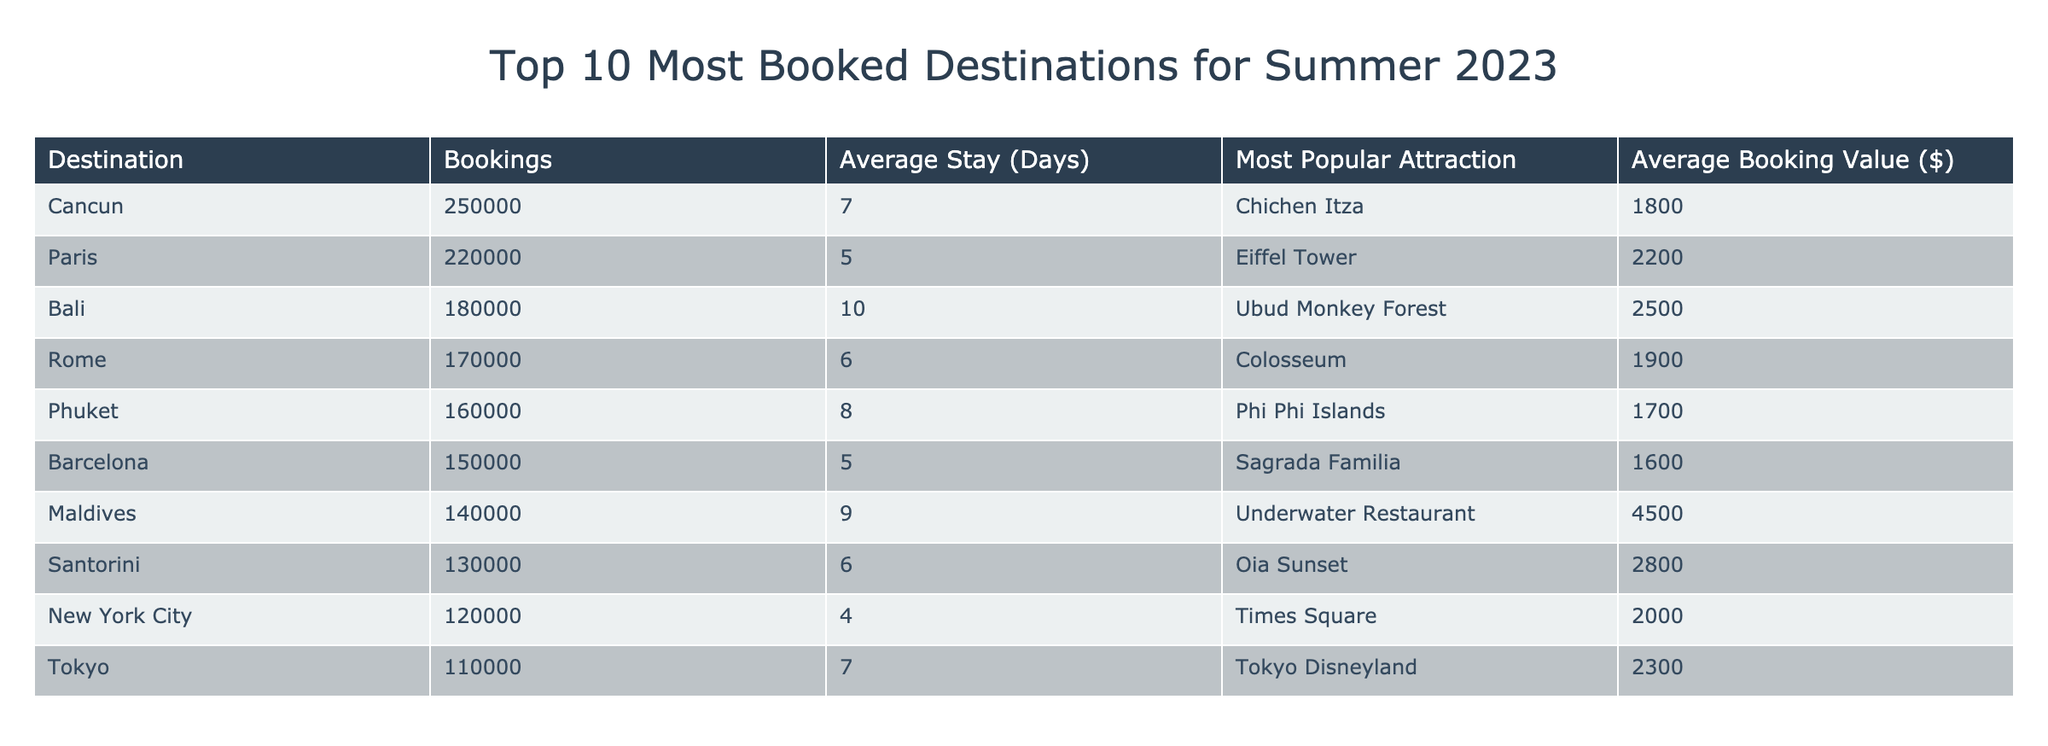What is the destination with the highest number of bookings? The destination with the highest number of bookings can be found in the "Bookings" column. By scanning the list, Cancun has the highest bookings at 250,000.
Answer: Cancun Which destination has the lowest average stay? The average stay can be determined by looking at the "Average Stay (Days)" column. Among the listed destinations, New York City has the lowest average stay at 4 days.
Answer: New York City What is the total number of bookings for the top three destinations? To find the total bookings for the top three destinations, we sum the bookings of Cancun (250,000), Paris (220,000), and Bali (180,000). The calculation is 250,000 + 220,000 + 180,000 = 650,000.
Answer: 650000 Is the average booking value for Bali greater than $2,000? The average booking value for Bali is listed as $2,500. Since $2,500 is greater than $2,000, the answer is yes.
Answer: Yes Which destination has the most popular attraction of Chichen Itza? The destination associated with the attraction "Chichen Itza" can be found by checking the "Most Popular Attraction" column. It is listed under Cancun.
Answer: Cancun What is the average booking value for destinations with an average stay greater than 7 days? First, we filter for destinations with an average stay greater than 7 days: Bali (10 days), Maldives (9 days). Their average booking values are $2,500 and $4,500 respectively. Summing them yields $2,500 + $4,500 = $7,000, then dividing by 2 gives us an average of $3,500.
Answer: 3500 Are there more than three destinations with an average stay of 6 days or less? Looking at the "Average Stay (Days)" column, the destinations with 6 days or less are Paris (5 days), Barcelona (5 days), New York City (4 days), and Rome (6 days). This sums to four destinations, thus the answer is yes.
Answer: Yes What is the difference in average booking value between the most booked and the least booked destination? The most booked destination is Cancun with an average booking value of $1,800. The least booked is Tokyo with an average booking value of $2,300. The difference is $1,800 - $2,300, which results in -$500, indicating that Tokyo's average booking value is higher.
Answer: -500 What is the most popular attraction for the destination with the highest bookings? From the table, the destination with the highest bookings is Cancun, whose most popular attraction is Chichen Itza.
Answer: Chichen Itza 